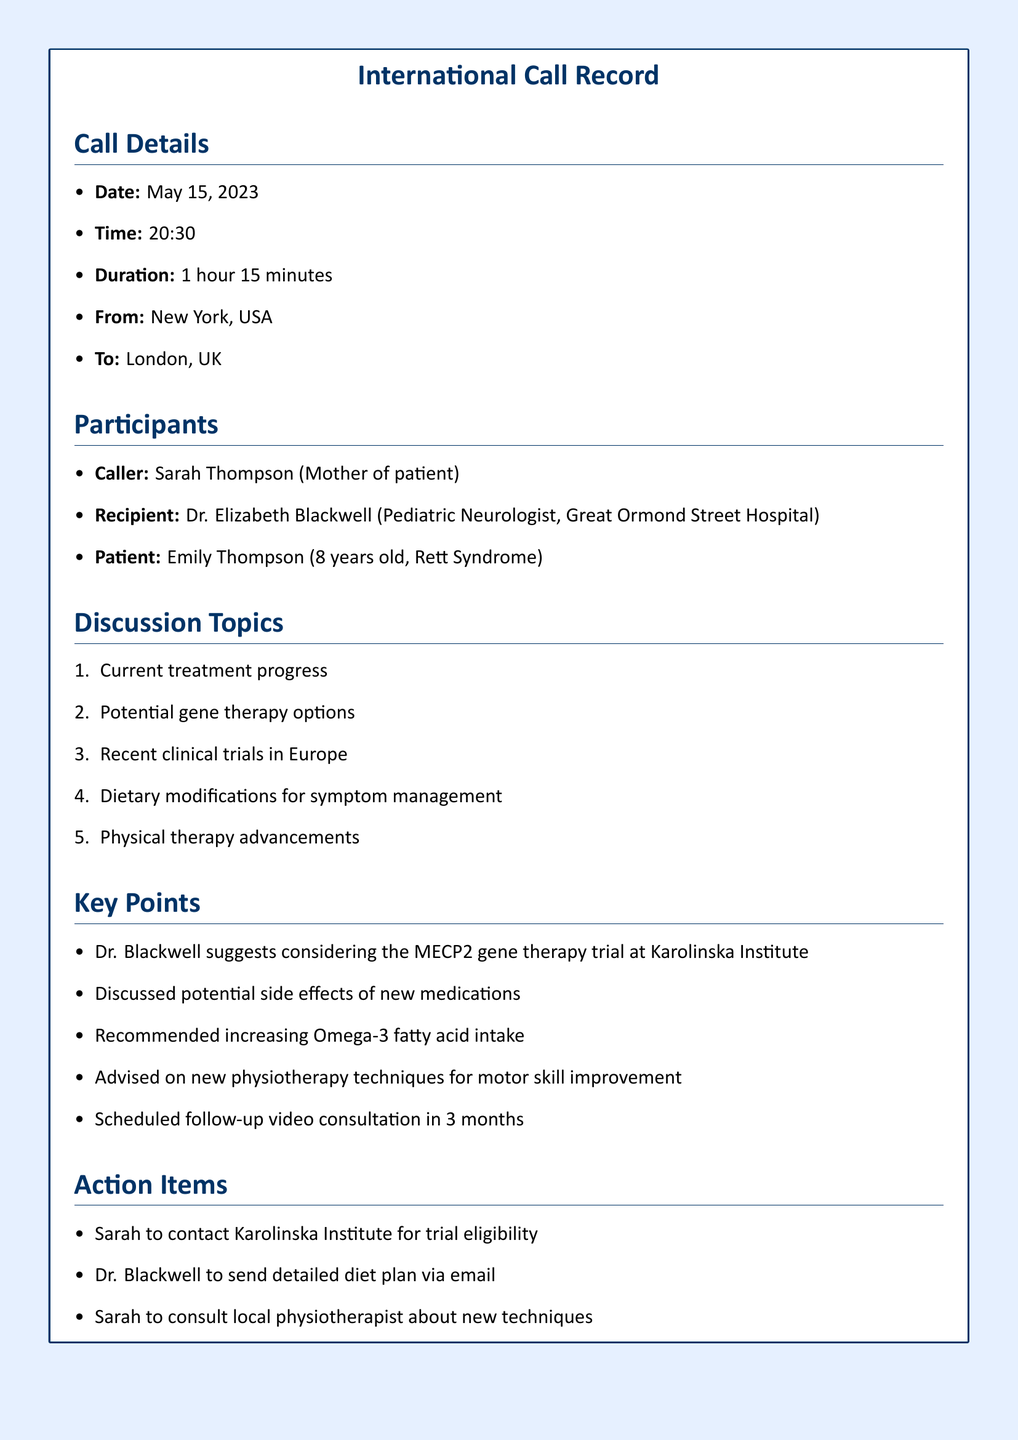What is the date of the call? The date of the call is clearly stated in the document.
Answer: May 15, 2023 Who is the recipient of the call? The recipient of the call is indicated in the participants section.
Answer: Dr. Elizabeth Blackwell What is the duration of the call? The duration of the call is mentioned under call details.
Answer: 1 hour 15 minutes What is the relationship of Sarah Thompson to the patient? The document identifies the role of Sarah Thompson in relation to the patient.
Answer: Mother What treatment option does Dr. Blackwell suggest? The discussion topics detail a specific treatment option discussed.
Answer: MECP2 gene therapy trial How many months until the next scheduled consultation? The follow-up consultation time is given in the action items section.
Answer: 3 months What dietary recommendation did Dr. Blackwell make? The key points outline relevant dietary modifications suggested during the call.
Answer: Omega-3 fatty acid intake What is the patient’s age? The patient’s age is provided in the participants list of the document.
Answer: 8 years old Where is Dr. Elizabeth Blackwell based? The location of Dr. Blackwell's institution is stated in the document.
Answer: Great Ormond Street Hospital 